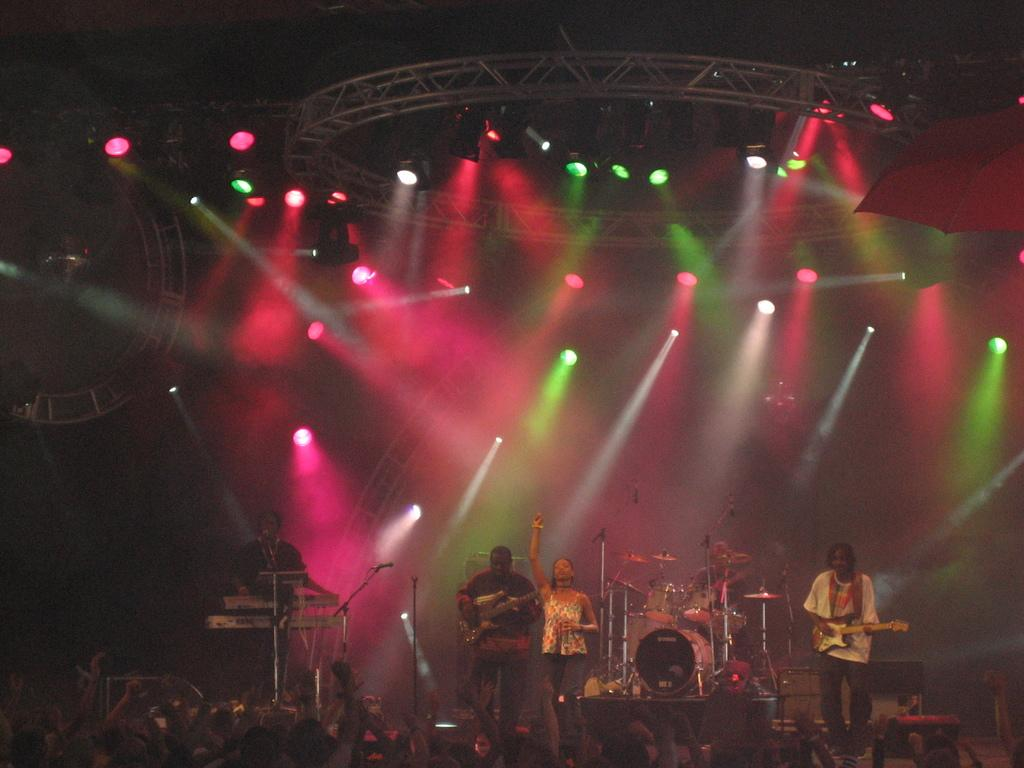What is happening in the image? There are many people standing near the stage, and there are people playing musical instruments. What can be seen in the background of the image? There are many lights visible in the image. What type of cabbage is being blown by the wind in the image? There is no cabbage or wind present in the image. How many seats are available for the audience in the image? The image does not show any seats for the audience, so it cannot be determined from the image. 